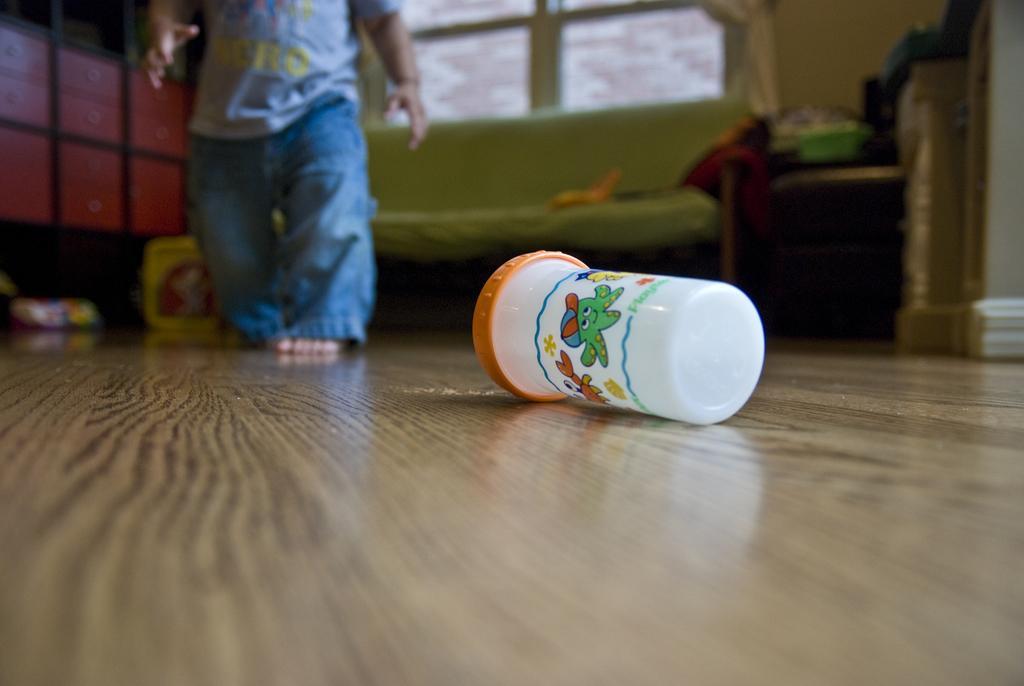How would you summarize this image in a sentence or two? In this image I can see a kid and a box on the floor. In the background I can see a wall, window, bed, table and shelves. This image is taken may be in a hall. 